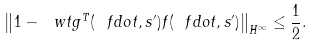<formula> <loc_0><loc_0><loc_500><loc_500>\left \| 1 - \ w t g ^ { T } ( \ f d o t , s ^ { \prime } ) f ( \ f d o t , s ^ { \prime } ) \right \| _ { H ^ { \infty } } \leq \frac { 1 } { 2 } .</formula> 